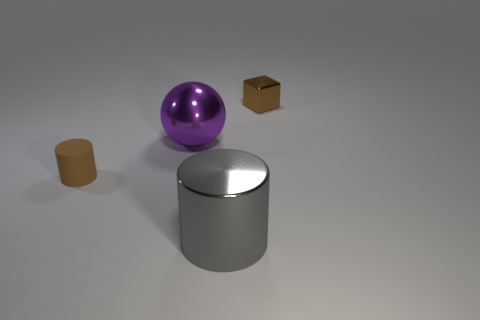
What size is the matte object that is the same color as the tiny shiny cube? The matte object sharing the same color as the tiny shiny cube is the cylinder, which is medium-sized in comparison to the other objects in the image. 